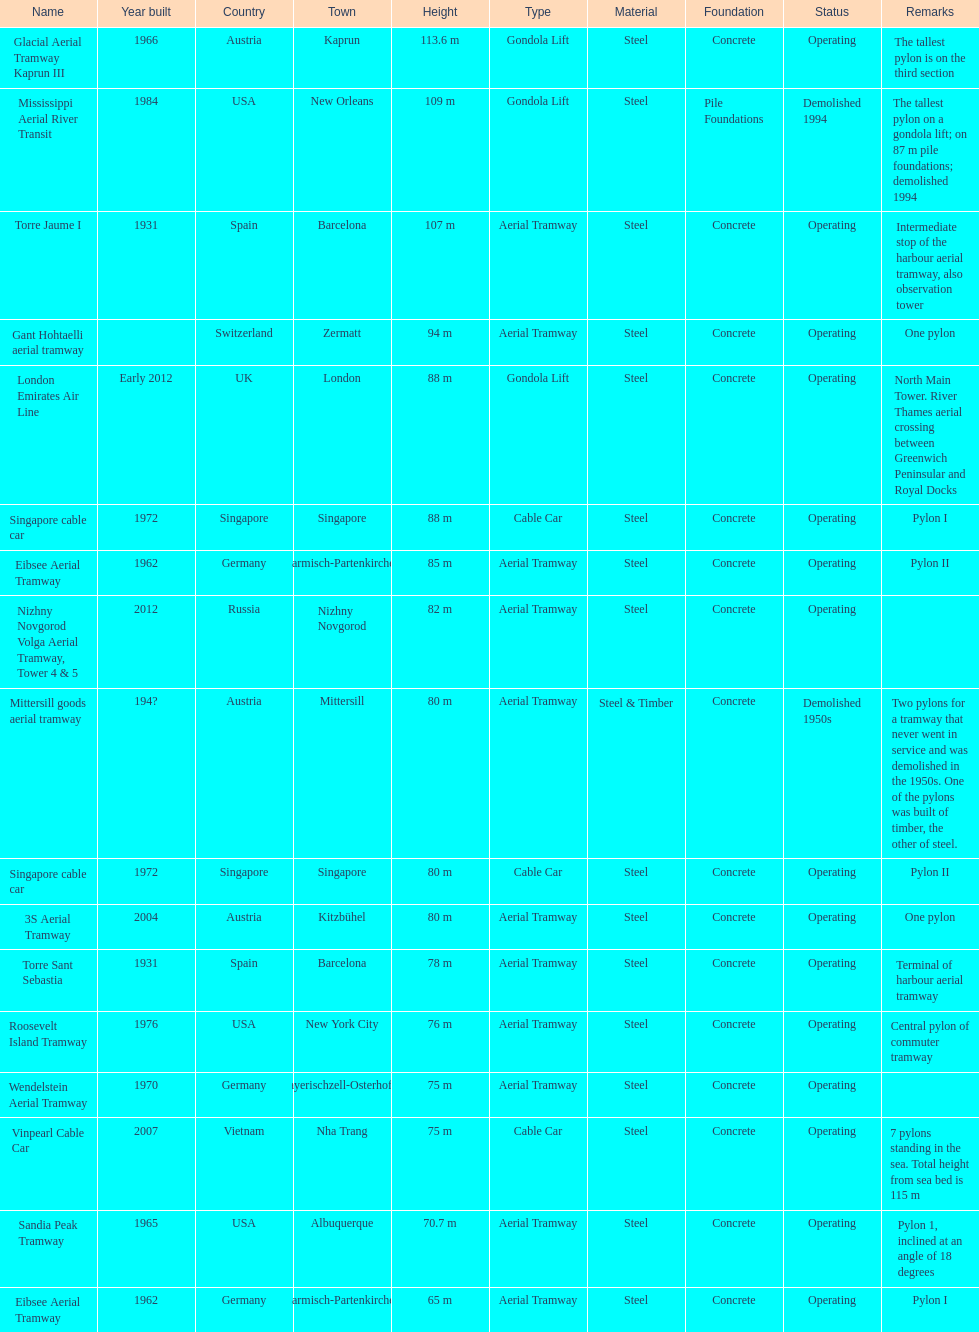On which pylon are the most observations made? Mittersill goods aerial tramway. 